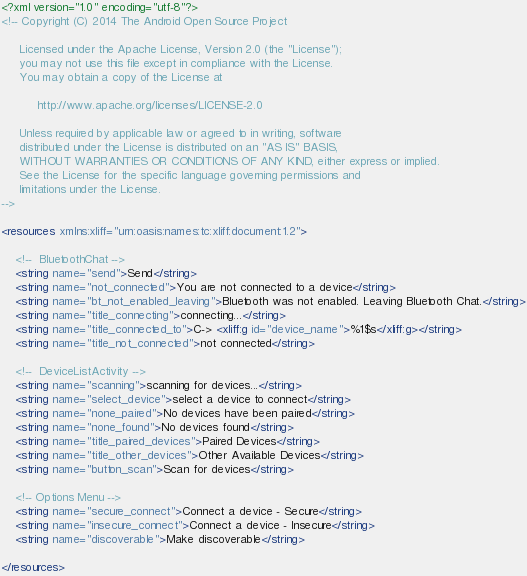<code> <loc_0><loc_0><loc_500><loc_500><_XML_><?xml version="1.0" encoding="utf-8"?>
<!-- Copyright (C) 2014 The Android Open Source Project

     Licensed under the Apache License, Version 2.0 (the "License");
     you may not use this file except in compliance with the License.
     You may obtain a copy of the License at

          http://www.apache.org/licenses/LICENSE-2.0

     Unless required by applicable law or agreed to in writing, software
     distributed under the License is distributed on an "AS IS" BASIS,
     WITHOUT WARRANTIES OR CONDITIONS OF ANY KIND, either express or implied.
     See the License for the specific language governing permissions and
     limitations under the License.
-->

<resources xmlns:xliff="urn:oasis:names:tc:xliff:document:1.2">

    <!--  BluetoothChat -->
    <string name="send">Send</string>
    <string name="not_connected">You are not connected to a device</string>
    <string name="bt_not_enabled_leaving">Bluetooth was not enabled. Leaving Bluetooth Chat.</string>
    <string name="title_connecting">connecting...</string>
    <string name="title_connected_to">C-> <xliff:g id="device_name">%1$s</xliff:g></string>
    <string name="title_not_connected">not connected</string>

    <!--  DeviceListActivity -->
    <string name="scanning">scanning for devices...</string>
    <string name="select_device">select a device to connect</string>
    <string name="none_paired">No devices have been paired</string>
    <string name="none_found">No devices found</string>
    <string name="title_paired_devices">Paired Devices</string>
    <string name="title_other_devices">Other Available Devices</string>
    <string name="button_scan">Scan for devices</string>

    <!-- Options Menu -->
    <string name="secure_connect">Connect a device - Secure</string>
    <string name="insecure_connect">Connect a device - Insecure</string>
    <string name="discoverable">Make discoverable</string>

</resources>
</code> 